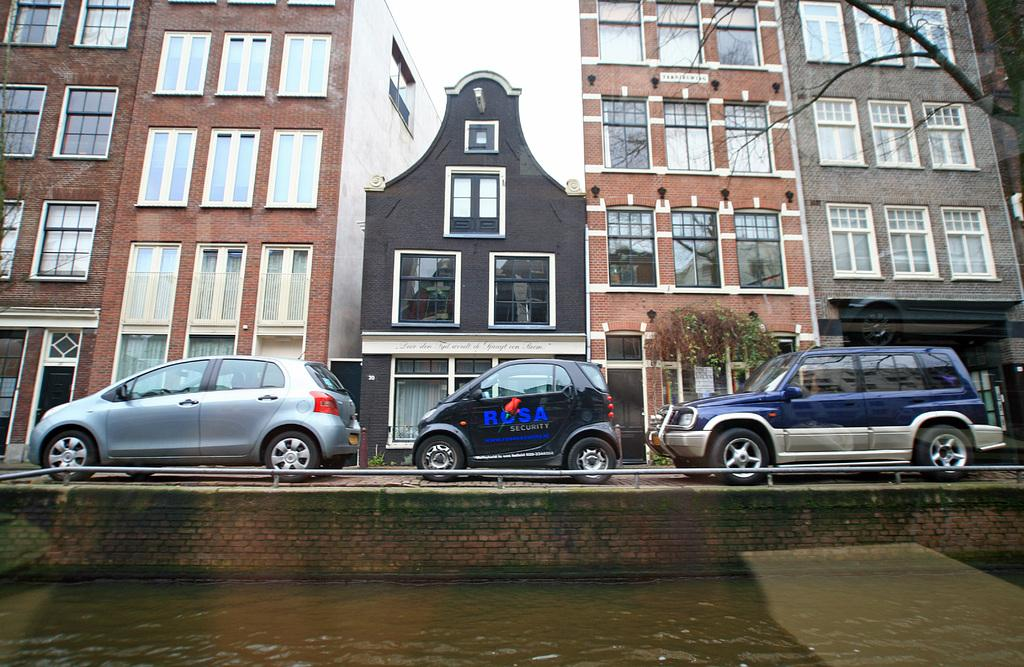What type of structures can be seen in the image? There are buildings in the image. What else is present in the image besides buildings? There are vehicles, trees, water, and the sky visible in the image. Can you describe the ground in the image? The ground is visible in the image. What is the condition of the sky in the image? The sky is visible in the image. What type of pear is being used to deliver the letter in the image? There is no pear or letter present in the image. 